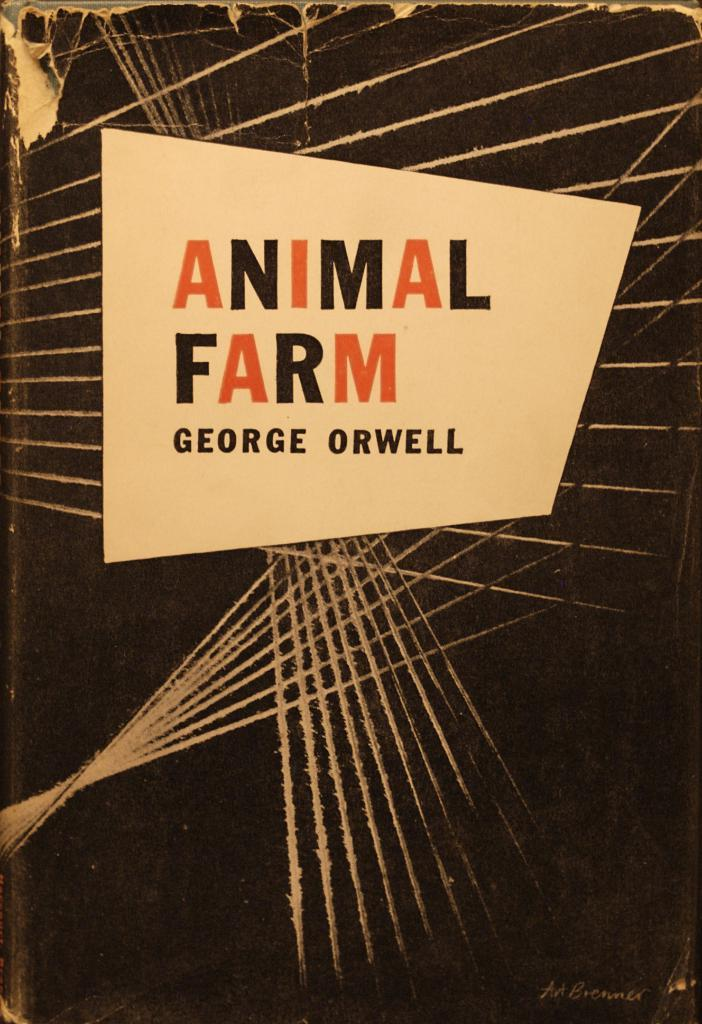<image>
Summarize the visual content of the image. A black, white, and orange book titled Animal Farm by George Orwell. 